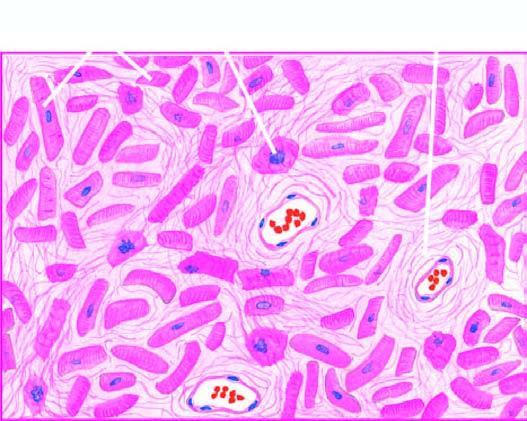what is there, especially around small blood vessels in the interstitium?
Answer the question using a single word or phrase. Patchy myocardial fibrosis 